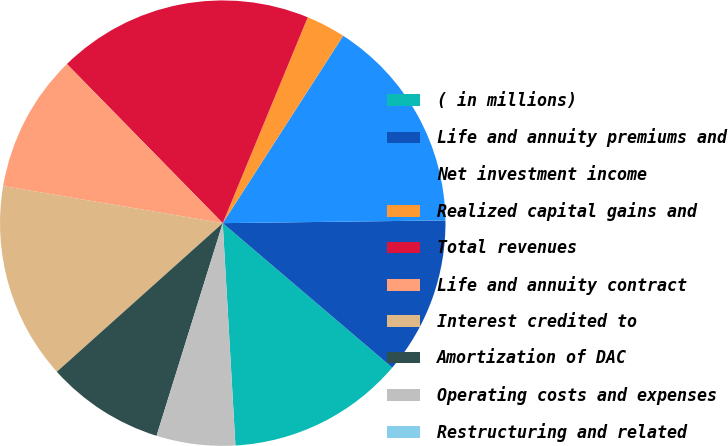Convert chart. <chart><loc_0><loc_0><loc_500><loc_500><pie_chart><fcel>( in millions)<fcel>Life and annuity premiums and<fcel>Net investment income<fcel>Realized capital gains and<fcel>Total revenues<fcel>Life and annuity contract<fcel>Interest credited to<fcel>Amortization of DAC<fcel>Operating costs and expenses<fcel>Restructuring and related<nl><fcel>12.86%<fcel>11.43%<fcel>15.71%<fcel>2.86%<fcel>18.57%<fcel>10.0%<fcel>14.29%<fcel>8.57%<fcel>5.71%<fcel>0.0%<nl></chart> 